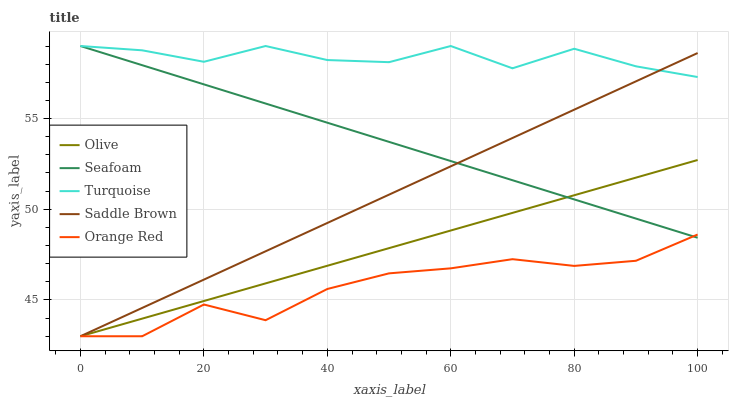Does Orange Red have the minimum area under the curve?
Answer yes or no. Yes. Does Turquoise have the maximum area under the curve?
Answer yes or no. Yes. Does Seafoam have the minimum area under the curve?
Answer yes or no. No. Does Seafoam have the maximum area under the curve?
Answer yes or no. No. Is Saddle Brown the smoothest?
Answer yes or no. Yes. Is Turquoise the roughest?
Answer yes or no. Yes. Is Seafoam the smoothest?
Answer yes or no. No. Is Seafoam the roughest?
Answer yes or no. No. Does Seafoam have the lowest value?
Answer yes or no. No. Does Seafoam have the highest value?
Answer yes or no. Yes. Does Orange Red have the highest value?
Answer yes or no. No. Is Olive less than Turquoise?
Answer yes or no. Yes. Is Turquoise greater than Olive?
Answer yes or no. Yes. Does Turquoise intersect Saddle Brown?
Answer yes or no. Yes. Is Turquoise less than Saddle Brown?
Answer yes or no. No. Is Turquoise greater than Saddle Brown?
Answer yes or no. No. Does Olive intersect Turquoise?
Answer yes or no. No. 